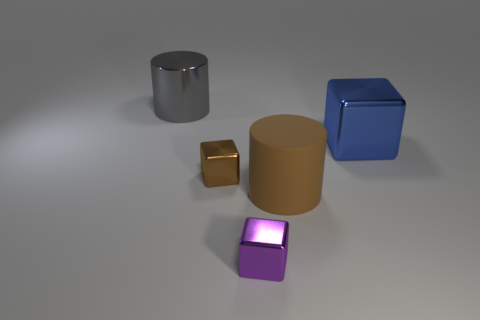Subtract all small brown shiny blocks. How many blocks are left? 2 Subtract all blue cubes. How many cubes are left? 2 Subtract 1 cylinders. How many cylinders are left? 1 Subtract all cylinders. How many objects are left? 3 Add 5 tiny brown blocks. How many objects exist? 10 Subtract 0 gray spheres. How many objects are left? 5 Subtract all green cylinders. Subtract all red balls. How many cylinders are left? 2 Subtract all brown cylinders. How many green cubes are left? 0 Subtract all large spheres. Subtract all purple metallic blocks. How many objects are left? 4 Add 1 blue shiny blocks. How many blue shiny blocks are left? 2 